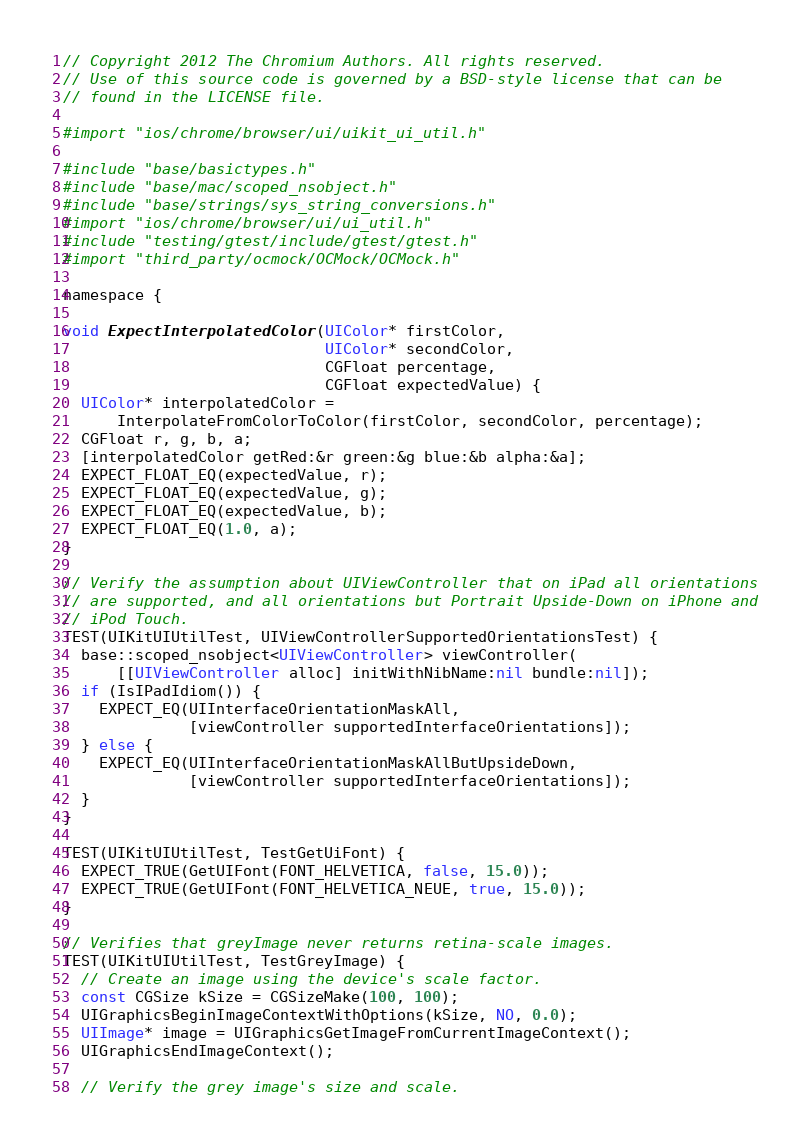Convert code to text. <code><loc_0><loc_0><loc_500><loc_500><_ObjectiveC_>// Copyright 2012 The Chromium Authors. All rights reserved.
// Use of this source code is governed by a BSD-style license that can be
// found in the LICENSE file.

#import "ios/chrome/browser/ui/uikit_ui_util.h"

#include "base/basictypes.h"
#include "base/mac/scoped_nsobject.h"
#include "base/strings/sys_string_conversions.h"
#import "ios/chrome/browser/ui/ui_util.h"
#include "testing/gtest/include/gtest/gtest.h"
#import "third_party/ocmock/OCMock/OCMock.h"

namespace {

void ExpectInterpolatedColor(UIColor* firstColor,
                             UIColor* secondColor,
                             CGFloat percentage,
                             CGFloat expectedValue) {
  UIColor* interpolatedColor =
      InterpolateFromColorToColor(firstColor, secondColor, percentage);
  CGFloat r, g, b, a;
  [interpolatedColor getRed:&r green:&g blue:&b alpha:&a];
  EXPECT_FLOAT_EQ(expectedValue, r);
  EXPECT_FLOAT_EQ(expectedValue, g);
  EXPECT_FLOAT_EQ(expectedValue, b);
  EXPECT_FLOAT_EQ(1.0, a);
}

// Verify the assumption about UIViewController that on iPad all orientations
// are supported, and all orientations but Portrait Upside-Down on iPhone and
// iPod Touch.
TEST(UIKitUIUtilTest, UIViewControllerSupportedOrientationsTest) {
  base::scoped_nsobject<UIViewController> viewController(
      [[UIViewController alloc] initWithNibName:nil bundle:nil]);
  if (IsIPadIdiom()) {
    EXPECT_EQ(UIInterfaceOrientationMaskAll,
              [viewController supportedInterfaceOrientations]);
  } else {
    EXPECT_EQ(UIInterfaceOrientationMaskAllButUpsideDown,
              [viewController supportedInterfaceOrientations]);
  }
}

TEST(UIKitUIUtilTest, TestGetUiFont) {
  EXPECT_TRUE(GetUIFont(FONT_HELVETICA, false, 15.0));
  EXPECT_TRUE(GetUIFont(FONT_HELVETICA_NEUE, true, 15.0));
}

// Verifies that greyImage never returns retina-scale images.
TEST(UIKitUIUtilTest, TestGreyImage) {
  // Create an image using the device's scale factor.
  const CGSize kSize = CGSizeMake(100, 100);
  UIGraphicsBeginImageContextWithOptions(kSize, NO, 0.0);
  UIImage* image = UIGraphicsGetImageFromCurrentImageContext();
  UIGraphicsEndImageContext();

  // Verify the grey image's size and scale.</code> 